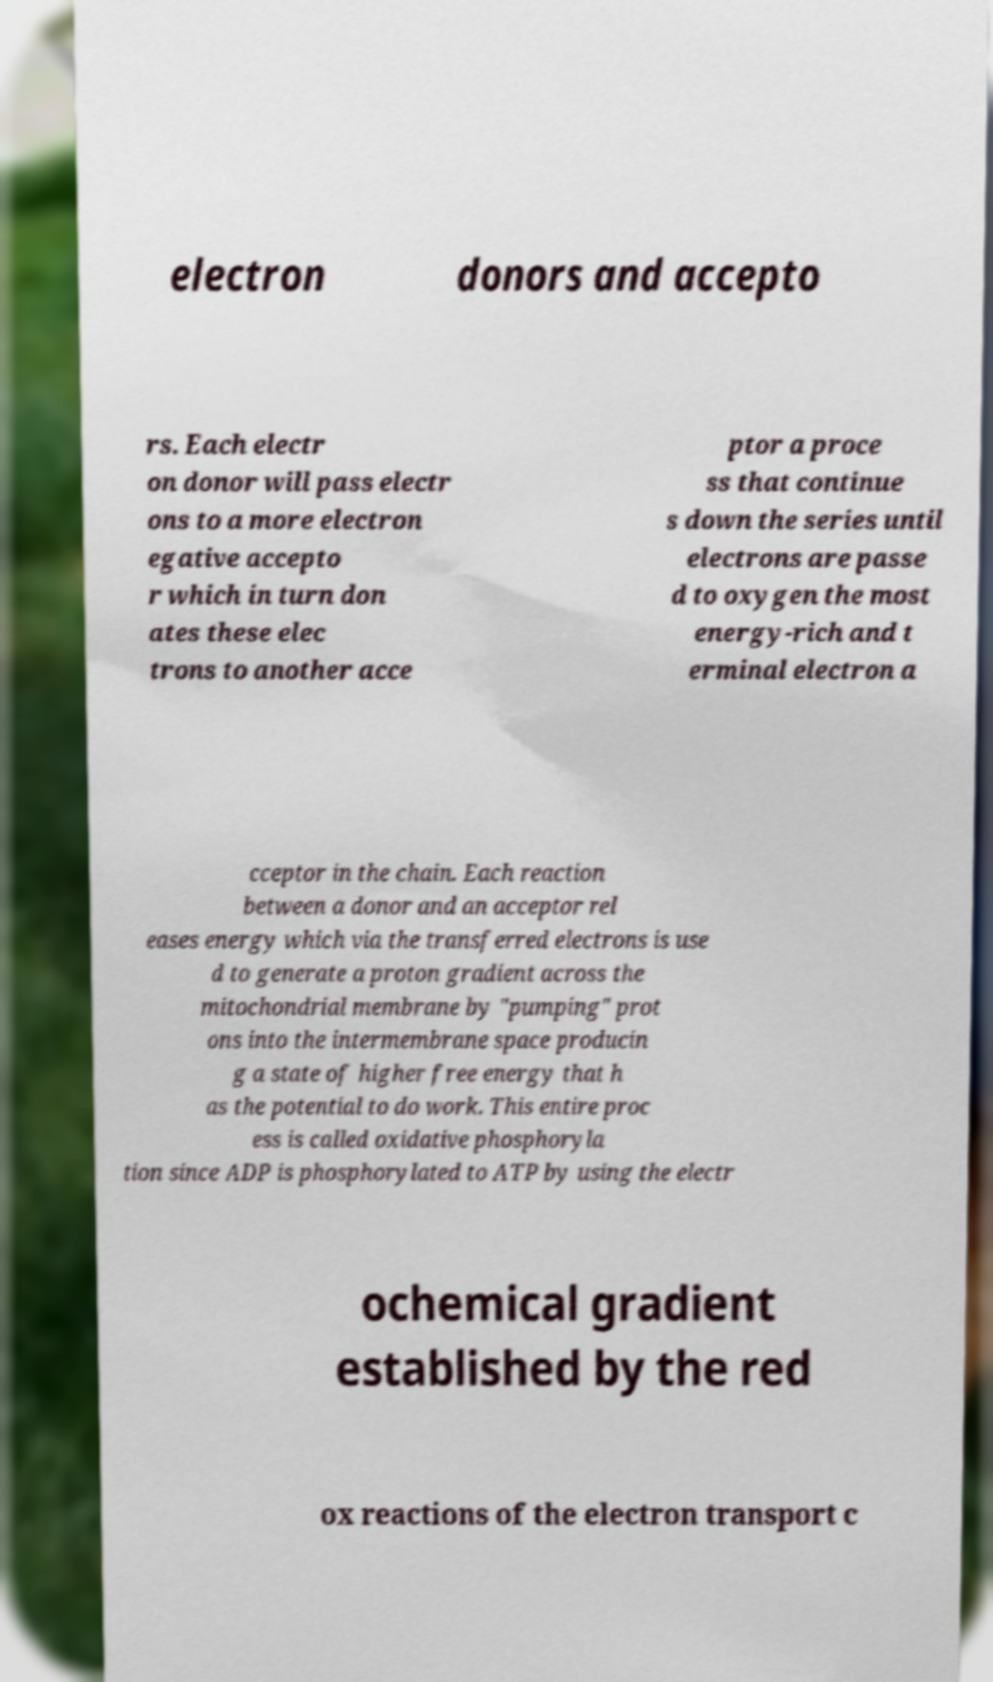I need the written content from this picture converted into text. Can you do that? electron donors and accepto rs. Each electr on donor will pass electr ons to a more electron egative accepto r which in turn don ates these elec trons to another acce ptor a proce ss that continue s down the series until electrons are passe d to oxygen the most energy-rich and t erminal electron a cceptor in the chain. Each reaction between a donor and an acceptor rel eases energy which via the transferred electrons is use d to generate a proton gradient across the mitochondrial membrane by "pumping" prot ons into the intermembrane space producin g a state of higher free energy that h as the potential to do work. This entire proc ess is called oxidative phosphoryla tion since ADP is phosphorylated to ATP by using the electr ochemical gradient established by the red ox reactions of the electron transport c 